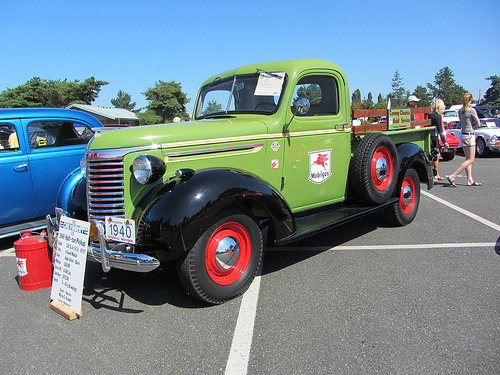<image>
Can you confirm if the truck is to the left of the girl? No. The truck is not to the left of the girl. From this viewpoint, they have a different horizontal relationship. 